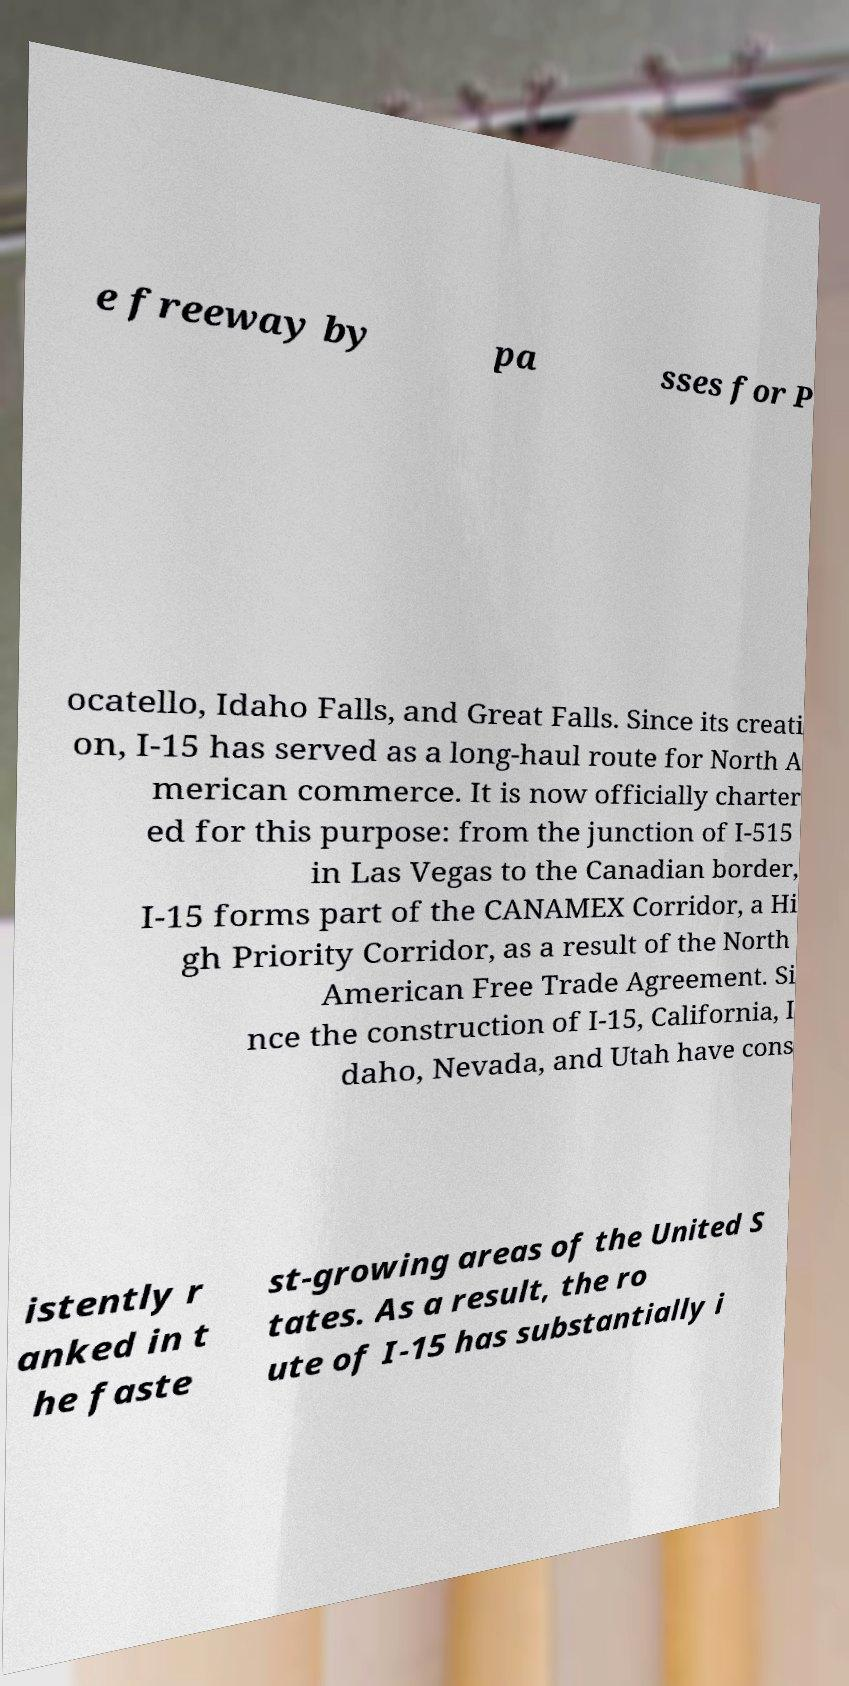For documentation purposes, I need the text within this image transcribed. Could you provide that? e freeway by pa sses for P ocatello, Idaho Falls, and Great Falls. Since its creati on, I-15 has served as a long-haul route for North A merican commerce. It is now officially charter ed for this purpose: from the junction of I-515 in Las Vegas to the Canadian border, I-15 forms part of the CANAMEX Corridor, a Hi gh Priority Corridor, as a result of the North American Free Trade Agreement. Si nce the construction of I-15, California, I daho, Nevada, and Utah have cons istently r anked in t he faste st-growing areas of the United S tates. As a result, the ro ute of I-15 has substantially i 